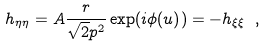Convert formula to latex. <formula><loc_0><loc_0><loc_500><loc_500>h _ { \eta \eta } = A \frac { r } { \sqrt { 2 } p ^ { 2 } } \exp ( { i \phi ( u ) } ) = - h _ { \xi \xi } \ ,</formula> 